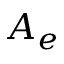Convert formula to latex. <formula><loc_0><loc_0><loc_500><loc_500>A _ { e }</formula> 